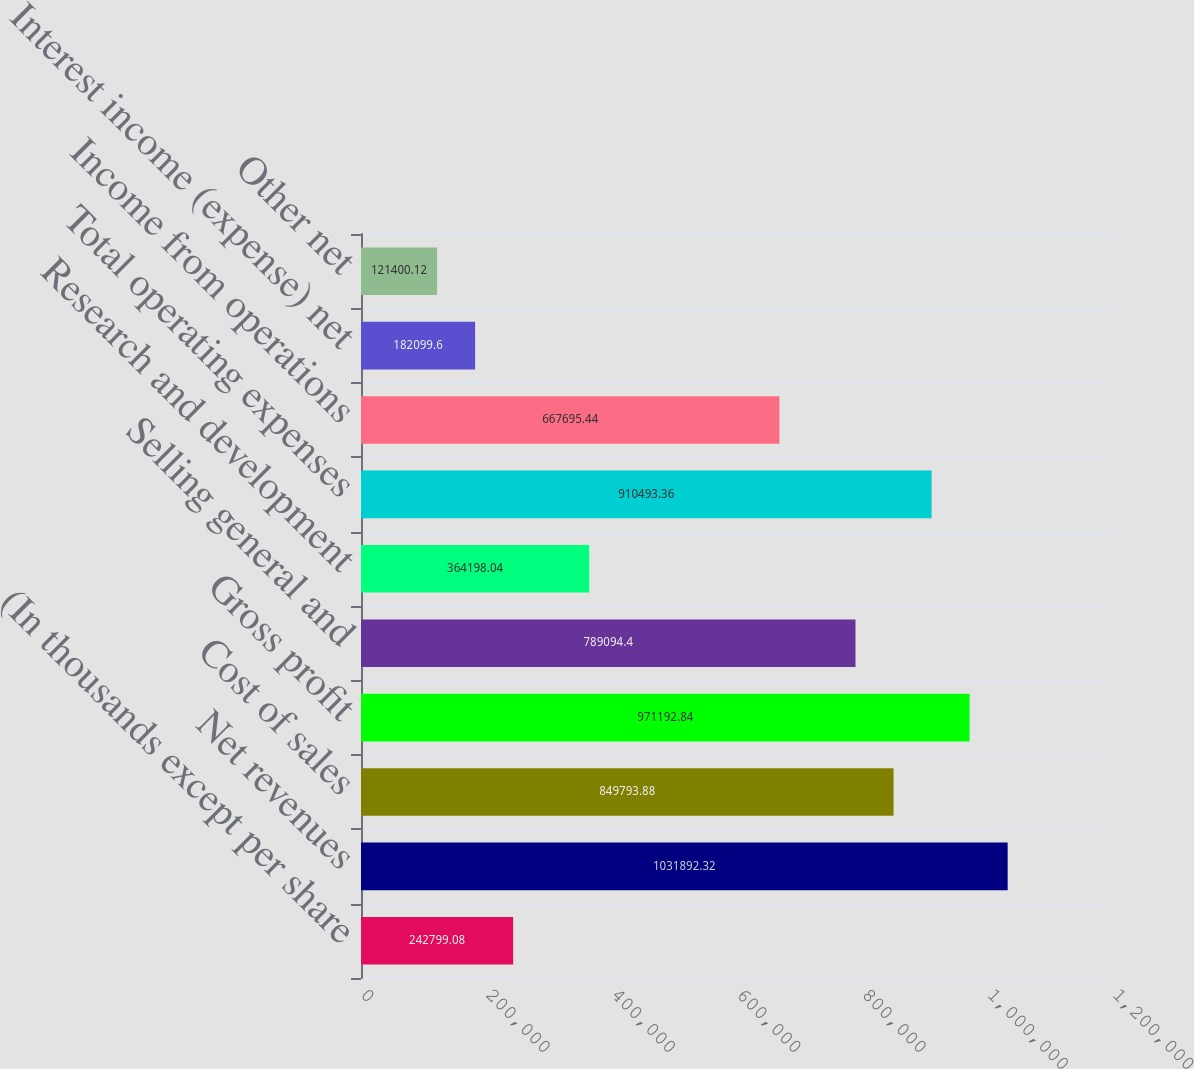<chart> <loc_0><loc_0><loc_500><loc_500><bar_chart><fcel>(In thousands except per share<fcel>Net revenues<fcel>Cost of sales<fcel>Gross profit<fcel>Selling general and<fcel>Research and development<fcel>Total operating expenses<fcel>Income from operations<fcel>Interest income (expense) net<fcel>Other net<nl><fcel>242799<fcel>1.03189e+06<fcel>849794<fcel>971193<fcel>789094<fcel>364198<fcel>910493<fcel>667695<fcel>182100<fcel>121400<nl></chart> 